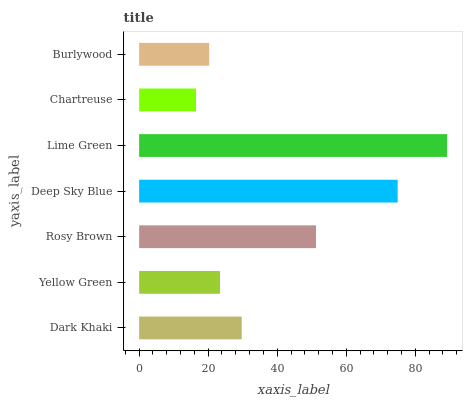Is Chartreuse the minimum?
Answer yes or no. Yes. Is Lime Green the maximum?
Answer yes or no. Yes. Is Yellow Green the minimum?
Answer yes or no. No. Is Yellow Green the maximum?
Answer yes or no. No. Is Dark Khaki greater than Yellow Green?
Answer yes or no. Yes. Is Yellow Green less than Dark Khaki?
Answer yes or no. Yes. Is Yellow Green greater than Dark Khaki?
Answer yes or no. No. Is Dark Khaki less than Yellow Green?
Answer yes or no. No. Is Dark Khaki the high median?
Answer yes or no. Yes. Is Dark Khaki the low median?
Answer yes or no. Yes. Is Yellow Green the high median?
Answer yes or no. No. Is Burlywood the low median?
Answer yes or no. No. 